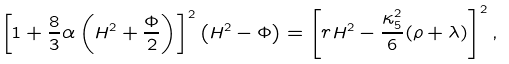Convert formula to latex. <formula><loc_0><loc_0><loc_500><loc_500>\left [ 1 + \frac { 8 } { 3 } \alpha \left ( H ^ { 2 } + \frac { \Phi } { 2 } \right ) \right ] ^ { 2 } \left ( H ^ { 2 } - \Phi \right ) = \left [ r H ^ { 2 } - \frac { \kappa ^ { 2 } _ { 5 } } { 6 } ( \rho + \lambda ) \right ] ^ { 2 } ,</formula> 